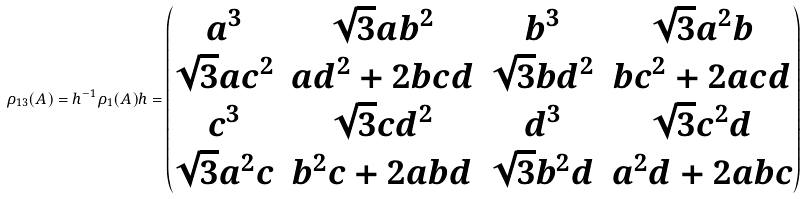Convert formula to latex. <formula><loc_0><loc_0><loc_500><loc_500>\rho _ { 1 3 } ( A ) = h ^ { - 1 } \rho _ { 1 } ( A ) h = \begin{pmatrix} a ^ { 3 } & \sqrt { 3 } a b ^ { 2 } & b ^ { 3 } & \sqrt { 3 } a ^ { 2 } b \\ \sqrt { 3 } a c ^ { 2 } & a d ^ { 2 } + 2 b c d & \sqrt { 3 } b d ^ { 2 } & b c ^ { 2 } + 2 a c d \\ c ^ { 3 } & \sqrt { 3 } c d ^ { 2 } & d ^ { 3 } & \sqrt { 3 } c ^ { 2 } d \\ \sqrt { 3 } a ^ { 2 } c & b ^ { 2 } c + 2 a b d & \sqrt { 3 } b ^ { 2 } d & a ^ { 2 } d + 2 a b c \end{pmatrix}</formula> 